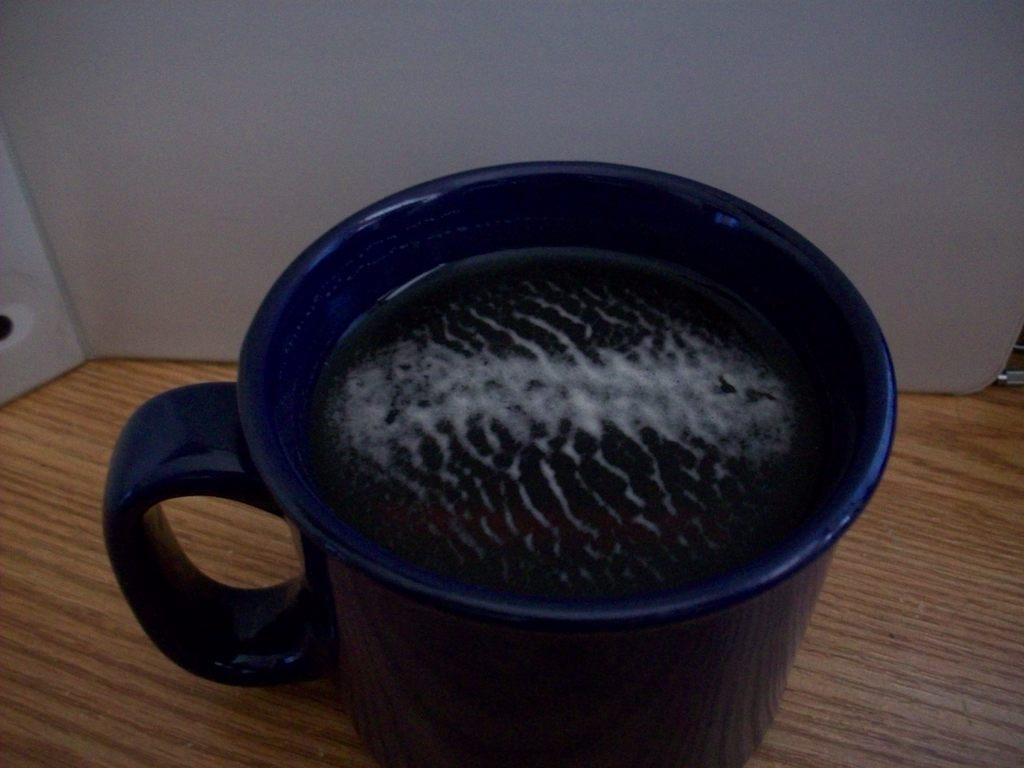What color is the cup that is visible in the image? There is a blue cup in the image. What is inside the cup? The cup contains some liquid. On what surface is the cup placed? The cup is on a wooden surface. What can be seen in the background of the image? There is a white wall in the background of the image. What type of thrill can be experienced at the airport in the image? There is no airport present in the image, and therefore no thrill can be experienced. 